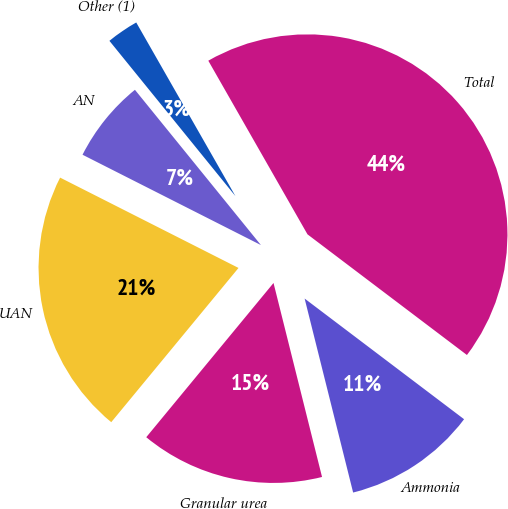Convert chart to OTSL. <chart><loc_0><loc_0><loc_500><loc_500><pie_chart><fcel>Ammonia<fcel>Granular urea<fcel>UAN<fcel>AN<fcel>Other (1)<fcel>Total<nl><fcel>10.79%<fcel>14.88%<fcel>21.48%<fcel>6.69%<fcel>2.59%<fcel>43.57%<nl></chart> 